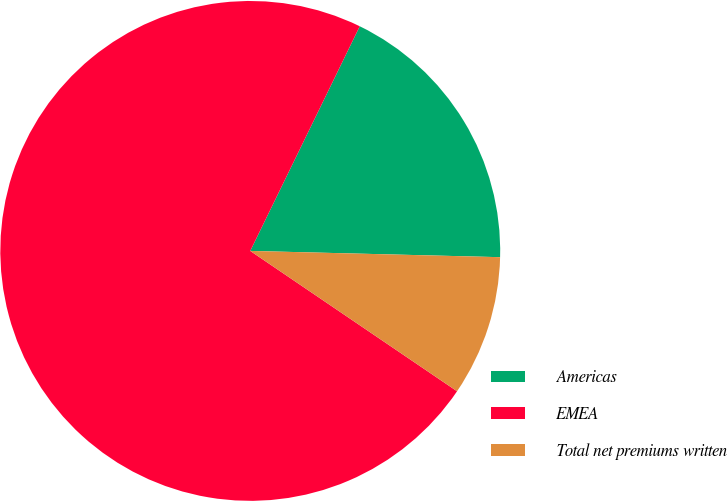Convert chart to OTSL. <chart><loc_0><loc_0><loc_500><loc_500><pie_chart><fcel>Americas<fcel>EMEA<fcel>Total net premiums written<nl><fcel>18.18%<fcel>72.73%<fcel>9.09%<nl></chart> 